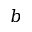<formula> <loc_0><loc_0><loc_500><loc_500>b</formula> 